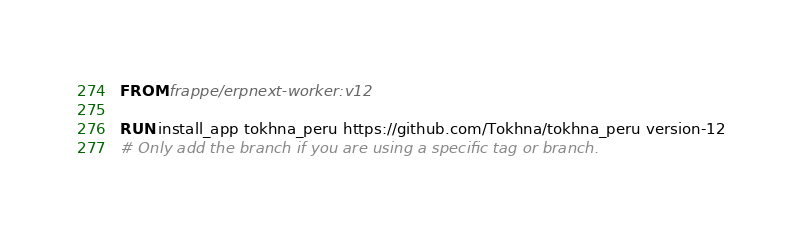<code> <loc_0><loc_0><loc_500><loc_500><_Dockerfile_>FROM frappe/erpnext-worker:v12

RUN install_app tokhna_peru https://github.com/Tokhna/tokhna_peru version-12
# Only add the branch if you are using a specific tag or branch.</code> 